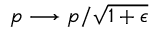<formula> <loc_0><loc_0><loc_500><loc_500>p \longrightarrow p / \sqrt { 1 + \epsilon }</formula> 